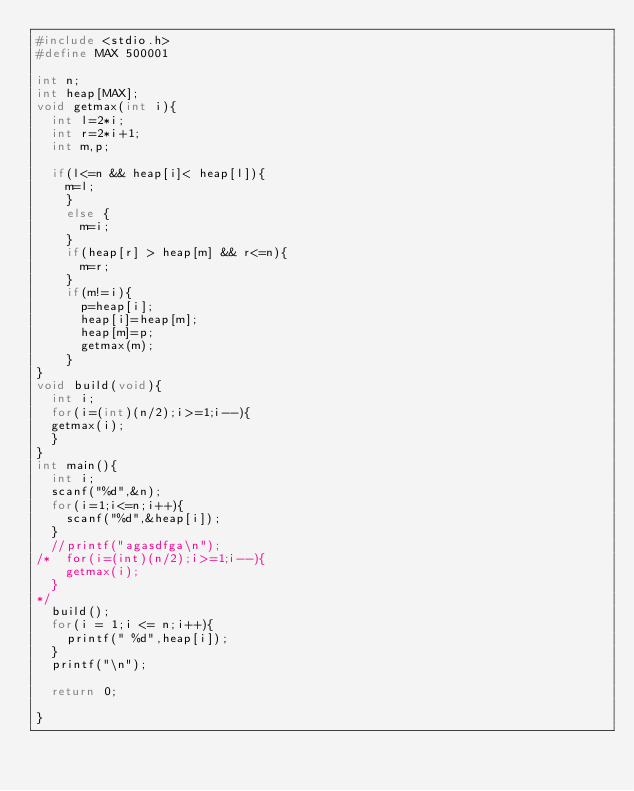Convert code to text. <code><loc_0><loc_0><loc_500><loc_500><_C_>#include <stdio.h>
#define MAX 500001

int n;
int heap[MAX];
void getmax(int i){
  int l=2*i;
  int r=2*i+1;
  int m,p;

  if(l<=n && heap[i]< heap[l]){
    m=l;
    }
    else {
      m=i;
    }
    if(heap[r] > heap[m] && r<=n){
      m=r;
    }
    if(m!=i){
      p=heap[i];
      heap[i]=heap[m];
      heap[m]=p;
      getmax(m);
    }
}
void build(void){
  int i;
  for(i=(int)(n/2);i>=1;i--){
  getmax(i);
  }
}
int main(){
  int i;
  scanf("%d",&n);
  for(i=1;i<=n;i++){
    scanf("%d",&heap[i]);
  }
  //printf("agasdfga\n");
/*  for(i=(int)(n/2);i>=1;i--){
    getmax(i);
  }
*/
  build();
  for(i = 1;i <= n;i++){
    printf(" %d",heap[i]);
  }
  printf("\n");

  return 0;

}</code> 